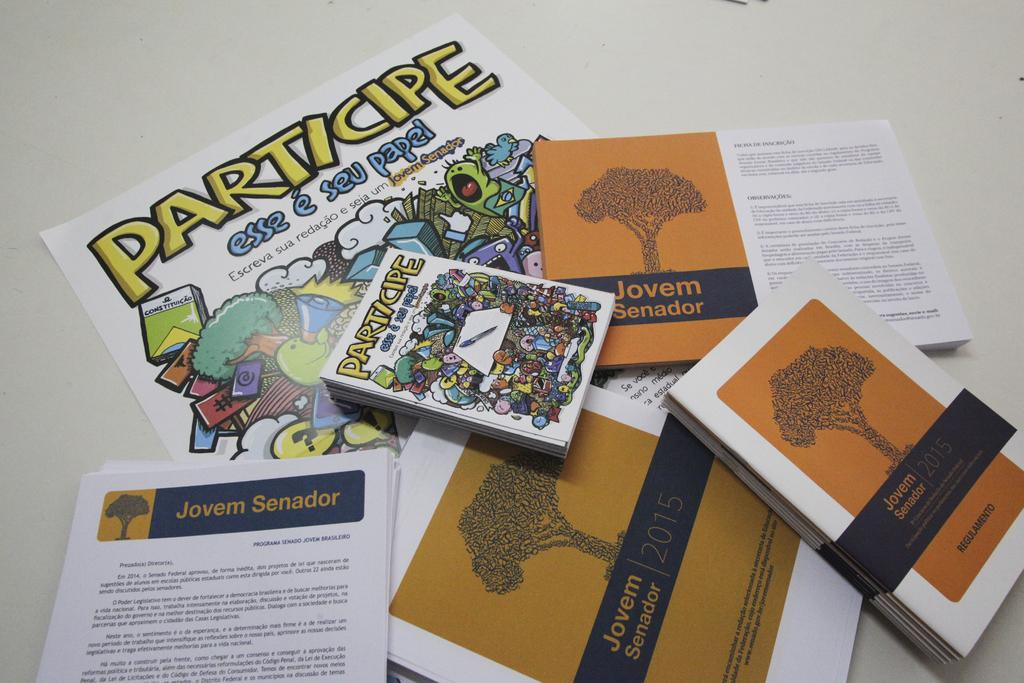<image>
Render a clear and concise summary of the photo. A table has party flyers that say Participe. 